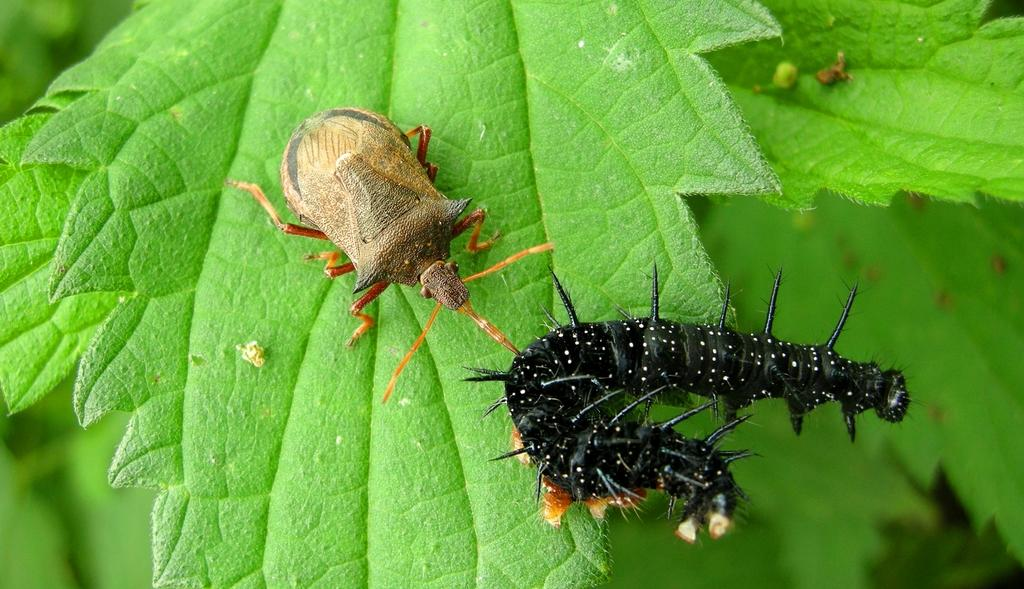What is the main subject of the image? The main subject of the image is insects on a leaf. Can you describe the background of the image? The background of the image is blurred. How much was the stamp used for payment in the image? There is no stamp or payment present in the image; it features insects on a leaf with a blurred background. 